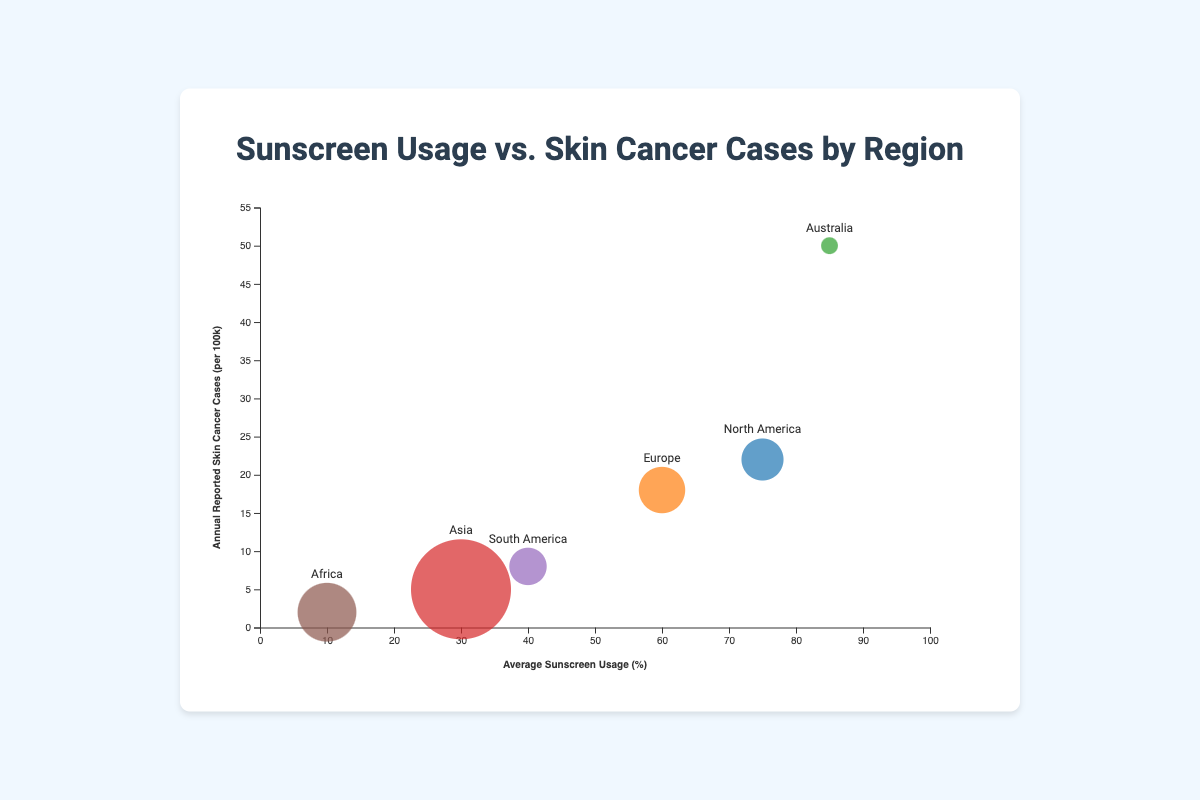What is the average sunscreen usage percentage for Europe? Looking at the bubble chart, find Europe and read the average sunscreen usage percentage value.
Answer: 60% Which region has the highest reported skin cancer cases per 100k? Identify the region with the highest value on the y-axis (Annual Reported Skin Cancer Cases). Australia has the highest value at 50 cases per 100k.
Answer: Australia Compare the sunscreen usage percentage between North America and South America. Which is higher? Locate both North America and South America on the chart and compare their x-axis values. North America has 75% sunscreen usage, while South America has 40%.
Answer: North America What is the relationship between sunscreen usage and skin cancer cases in Australia? In Australia, despite having high sunscreen usage (85%), the annual reported skin cancer cases are also high (50 per 100k).
Answer: High usage, high cases How many regions have an average sunscreen usage percentage above 50%? Count the bubbles that have an average sunscreen usage percentage greater than 50% by checking the x-axis. North America (75%), Europe (60%), and Australia (85%) fulfill this criterion, making a total of 3 regions.
Answer: 3 What does the size of the bubbles represent in the chart? The size of the bubbles represents the population in millions. The larger the bubble, the larger the population of the region.
Answer: Population size Which region has the smallest population, and what is their skin cancer rate per 100k? Locate the smallest bubble on the chart, which represents Australia with a population of 26 million. Their skin cancer rate is 50 per 100k.
Answer: Australia, 50 per 100k Is there any region with below 20% sunscreen usage and skin cancer cases above 5 per 100k? Examine the chart for regions below 20% on the x-axis and with a y-value of above 5 per 100k. No such region exists in the data.
Answer: No Compare Asia and Africa in terms of sunscreen usage and skin cancer cases. Asia has 30% sunscreen usage and 5 cases per 100k; Africa has 10% sunscreen usage and 2 cases per 100k. Therefore, Asia has higher values for both metrics.
Answer: Asia has higher usage and cases Calculate the average of the annual reported skin cancer cases per 100k for all regions. Sum all the reported skin cancer cases per 100k (22 + 18 + 50 + 5 + 8 + 2 = 105) and then divide by the number of regions (6). Average = 105/6 = 17.5
Answer: 17.5 